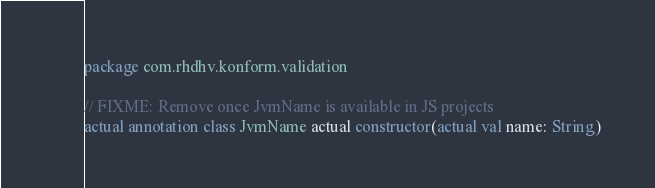Convert code to text. <code><loc_0><loc_0><loc_500><loc_500><_Kotlin_>package com.rhdhv.konform.validation

// FIXME: Remove once JvmName is available in JS projects
actual annotation class JvmName actual constructor(actual val name: String)
</code> 